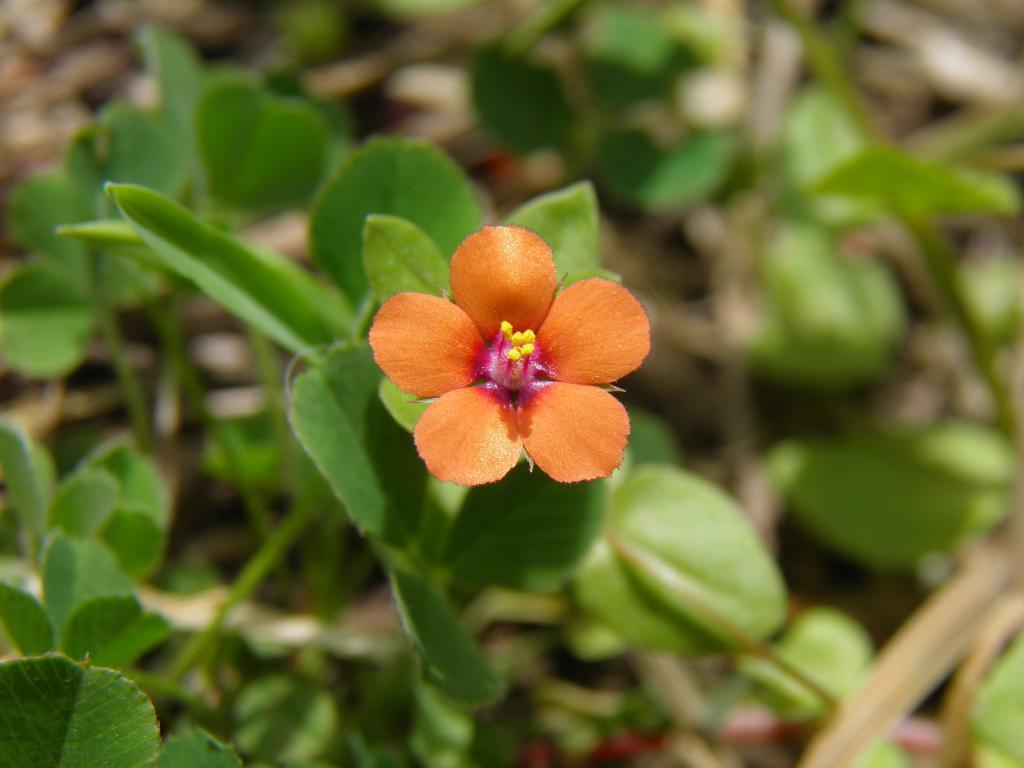What type of plant is visible in the image? There is a flower in the image. Are there any other plants present in the image besides the flower? Yes, there are plants in the image. What type of noise can be heard coming from the baby in the image? There is no baby present in the image, so it is not possible to determine what noise might be heard. 